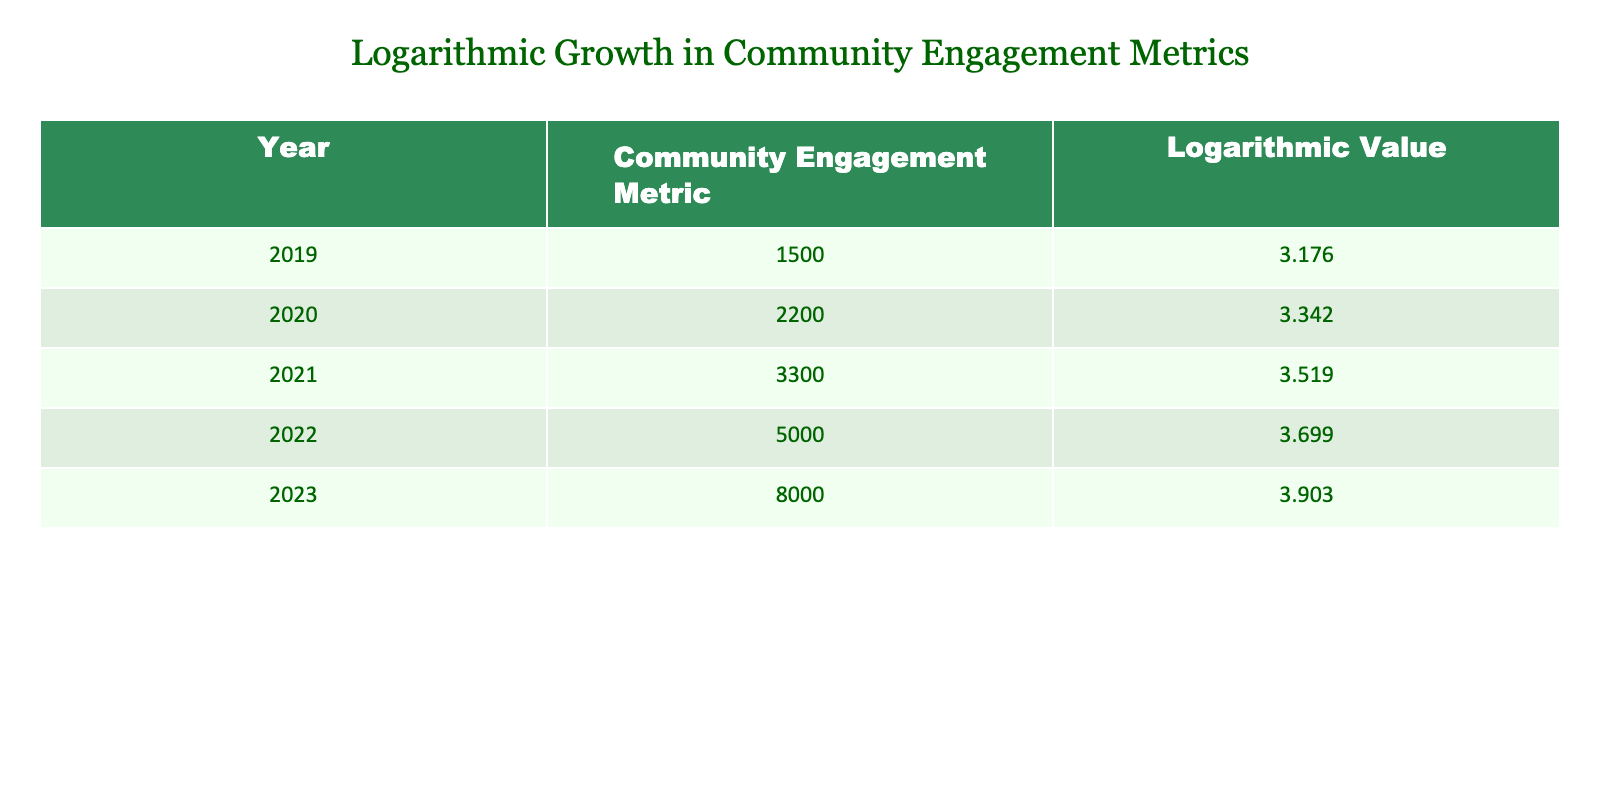What was the community engagement metric in 2022? The table shows that the community engagement metric for the year 2022 is 5000.
Answer: 5000 What was the logarithmic value for the community engagement metric in 2020? According to the table, in the year 2020, the logarithmic value is 3.342.
Answer: 3.342 What is the average community engagement metric over the five years? To find the average, sum the values: (1500 + 2200 + 3300 + 5000 + 8000) = 20000. Then divide by 5 (the number of years): 20000 / 5 = 4000.
Answer: 4000 Was the community engagement metric higher in 2023 than in 2019? The table indicates that in 2023 the metric was 8000, while in 2019 it was 1500. Since 8000 is greater than 1500, the answer is yes.
Answer: Yes What was the percentage increase in the community engagement metric from 2021 to 2023? To calculate the percentage increase, take the difference between the two years' metrics: 8000 - 3300 = 4700. Then divide by the 2021 metric and multiply by 100: (4700 / 3300) * 100 ≈ 142.42%.
Answer: 142.42% What was the logarithmic value in 2021 compared to 2020? In 2021, the logarithmic value is 3.519 and in 2020 it is 3.342. Since 3.519 is greater than 3.342, we can conclude that the logarithmic value increased from 2020 to 2021.
Answer: Increased What is the difference in community engagement metrics between 2022 and 2020? The metric in 2022 is 5000 and in 2020 it is 2200. The difference is calculated as: 5000 - 2200 = 2800.
Answer: 2800 Has the logarithmic value increased every year from 2019 to 2023? By examining the values in the table, we observe that the logarithmic values for each year are successive: 3.176, 3.342, 3.519, 3.699, and 3.903. Since each value is higher than the previous one, the answer is yes.
Answer: Yes What is the total of logarithmic values from 2019 to 2023? Adding the logarithmic values together: 3.176 + 3.342 + 3.519 + 3.699 + 3.903 = 17.639.
Answer: 17.639 